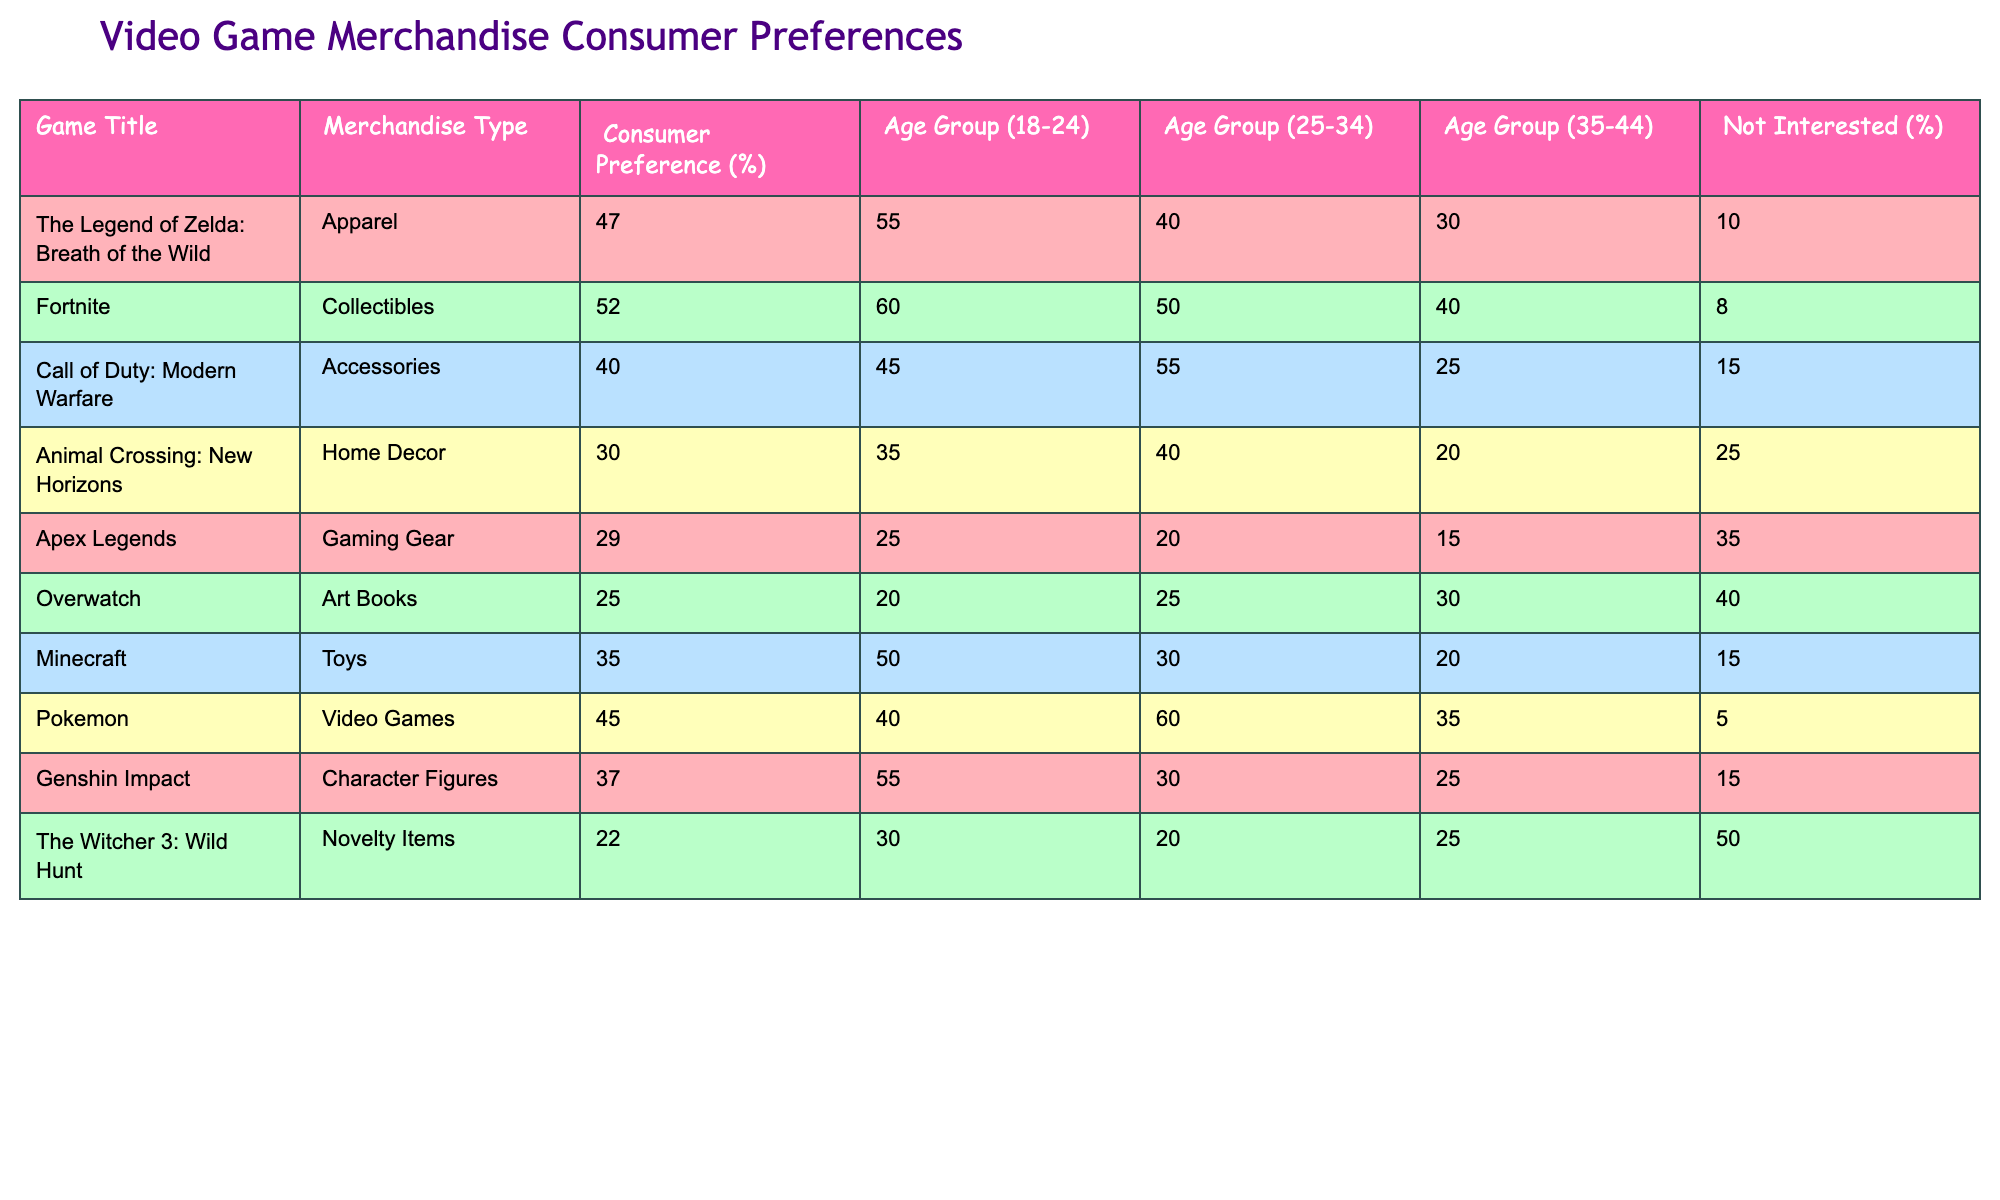What is the consumer preference percentage for Fortnite collectibles? The table shows that the consumer preference for Fortnite collectibles is listed as 52%.
Answer: 52% Which game title has the highest consumer preference for merchandise, and what is that percentage? The table indicates that Fortnite has the highest consumer preference at 52%.
Answer: Fortnite, 52% For which age group is the preference for The Legend of Zelda merchandise the highest? According to the table, the preference for The Legend of Zelda merchandise is highest in the age group 18-24, with a percentage of 55%.
Answer: Age group 18-24 What is the average consumer preference percentage for the merchandise types related to Animal Crossing, Apex Legends, and Overwatch? Summing the preferences of Animal Crossing (30%), Apex Legends (29%), and Overwatch (25%) gives us 84%. Dividing by 3 gives an average of 28%.
Answer: 28% Is it true that Genshin Impact character figures have a greater consumer preference among the 25-34 age group compared to Call of Duty accessories? The table states that Genshin Impact has a consumer preference of 30% for the 25-34 age group, while Call of Duty has a preference of 55%, so it is false.
Answer: No Which two games show a preference percentage for their merchandise below 30% among those surveyed? The preferences for merchandise below 30% are seen in Apex Legends (29%) and Overwatch (25%).
Answer: Apex Legends and Overwatch What is the difference in consumer preference between Minecraft toys and Animal Crossing home decor? Minecraft toys have a preference of 35%, while Animal Crossing home decor has 30%. The difference is 5%.
Answer: 5% What percentage of consumers are not interested in merchandise related to The Witcher 3: Wild Hunt? The table shows that the percentage of consumers not interested in merchandise related to The Witcher 3: Wild Hunt is 50%.
Answer: 50% What are the preferred merchandise types for the oldest age group surveyed (35-44), and which has the highest preference? In the 35-44 age group, the preferences are Call of Duty accessories (55%), Animal Crossing home decor (40%), and others lesser; the highest is Call of Duty, with 55%.
Answer: Call of Duty accessories, 55% 